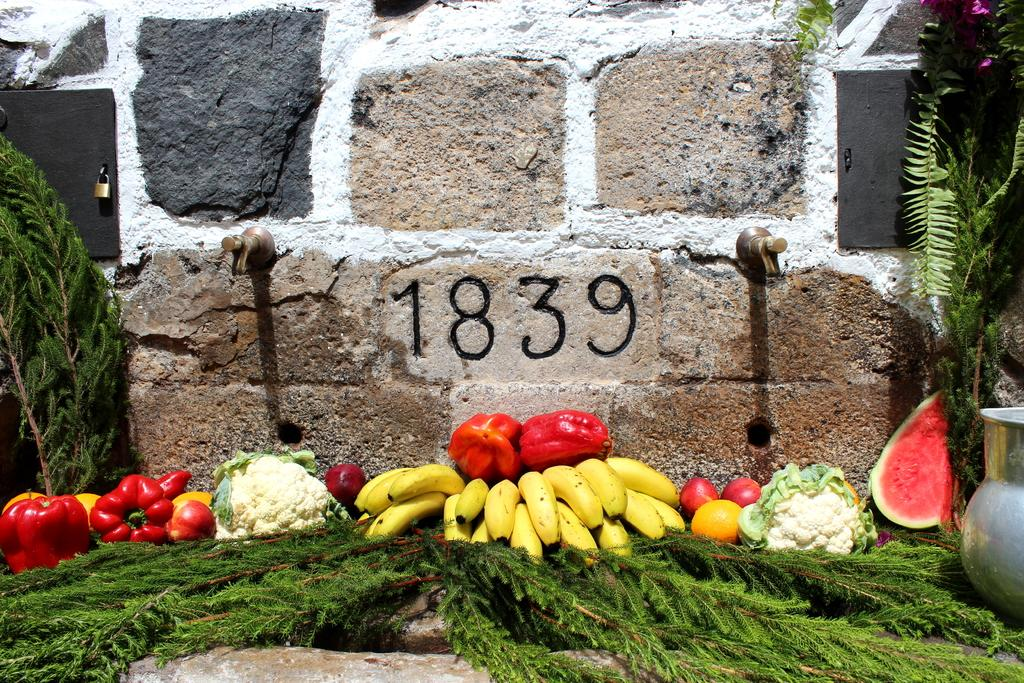What types of food items can be seen in the image? There are fruits and vegetables in the image. What is placed on the floor in the image? There is grass placed on the floor in the image. What can be seen attached to the wall in the background of the image? There are taps attached to the wall in the background of the image. How is the wall constructed in the image? The wall is built with cobblestones. Can you tell me how many channels are visible in the image? There are no channels present in the image; it features fruits, vegetables, grass, taps, and a cobblestone wall. 